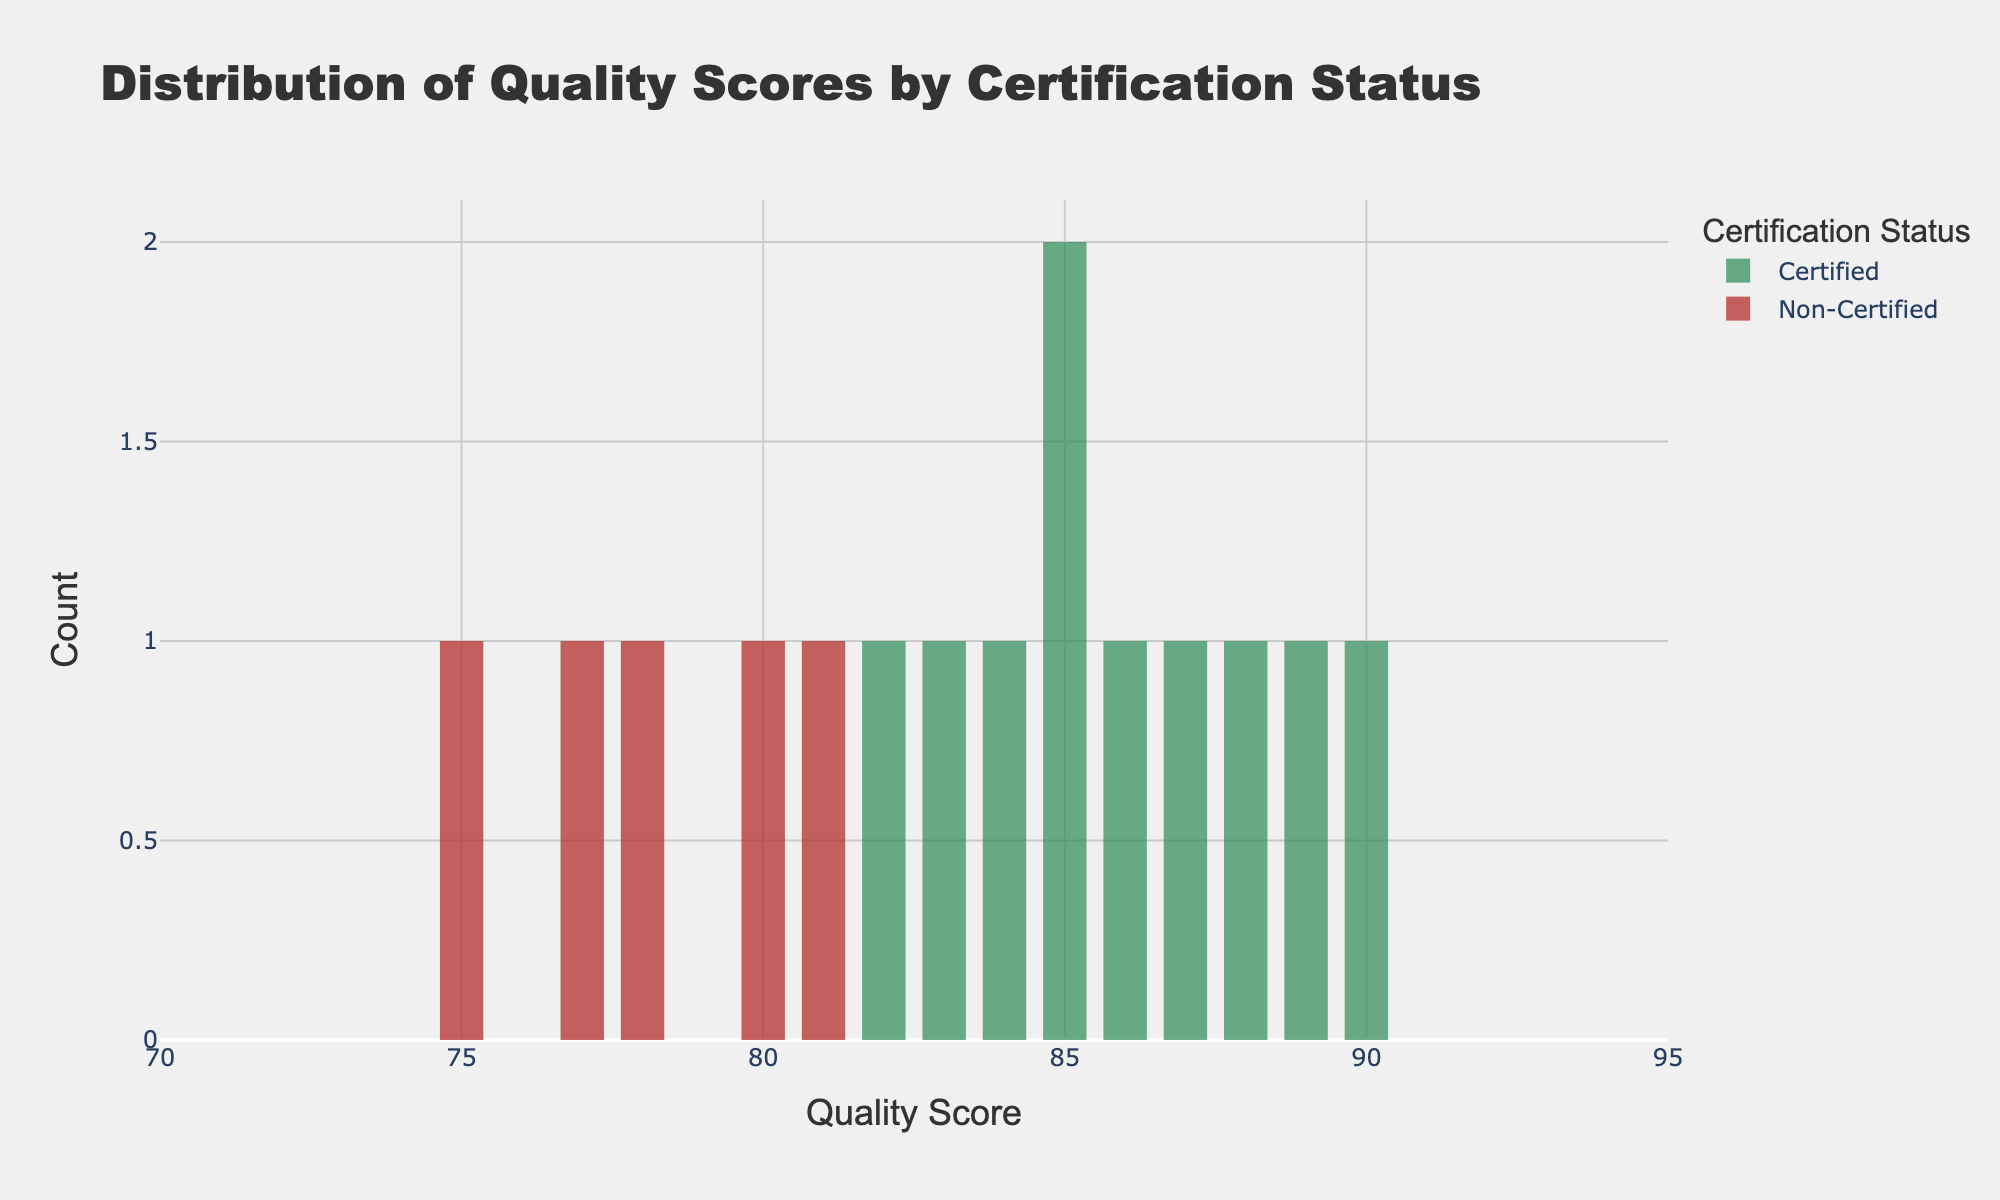What is the title of the figure? The title is displayed at the top of the figure, and it reads "Distribution of Quality Scores by Certification Status."
Answer: Distribution of Quality Scores by Certification Status How many bins are used to create the histogram for certified suppliers? By examining the histogram bars, we can see that there are 10 distinct intervals for the certified suppliers.
Answer: 10 Which certification status has suppliers with the highest quality score and what is that score? The highest score can be identified by looking at the rightmost bars: Certified suppliers have the highest quality score of 90.
Answer: Certified, 90 What is the range of quality scores displayed on the x-axis? The x-axis range can be determined by examining the range values at both ends of the axis, which span from 70 to 95.
Answer: 70 to 95 How many certified suppliers have a quality score greater than 85? By examining the histogram bars for certified suppliers and counting those in bins greater than 85, there are 5 certified suppliers with a quality score over 85.
Answer: 5 Which group of suppliers has more variability in their quality scores? By comparing the spread and variability of the two histograms, non-certified suppliers have quality scores ranging from approximately 75 to 81, indicating higher variability compared to certified suppliers.
Answer: Non-certified What is the most frequent quality score range for certified suppliers? The most frequent quality score range can be found by identifying the bin with the highest bar, which is around 85 for certified suppliers.
Answer: Around 85 Compare the mean quality scores of certified and non-certified suppliers. To find the means, we calculate the average of each group. Certified: (85+90+88+82+87+85+84+89+83+86)/10 = 85.9; Non-certified: (78+80+75+77+81)/5 = 78.2.
Answer: Certified mean: 85.9, Non-certified mean: 78.2 During which quality score range do certified suppliers have almost no representation? By examining the gaps in the histogram for certified suppliers, they have almost no representation in the 70-75 quality score range.
Answer: 70-75 Which certification status shows bars with more opacity in the histogram, and what does that indicate? Observation tells us that both certification statuses use the same opacity setting, but the bars for non-certified suppliers are less clustered, indicating fewer data points.
Answer: Non-certified, fewer data points 